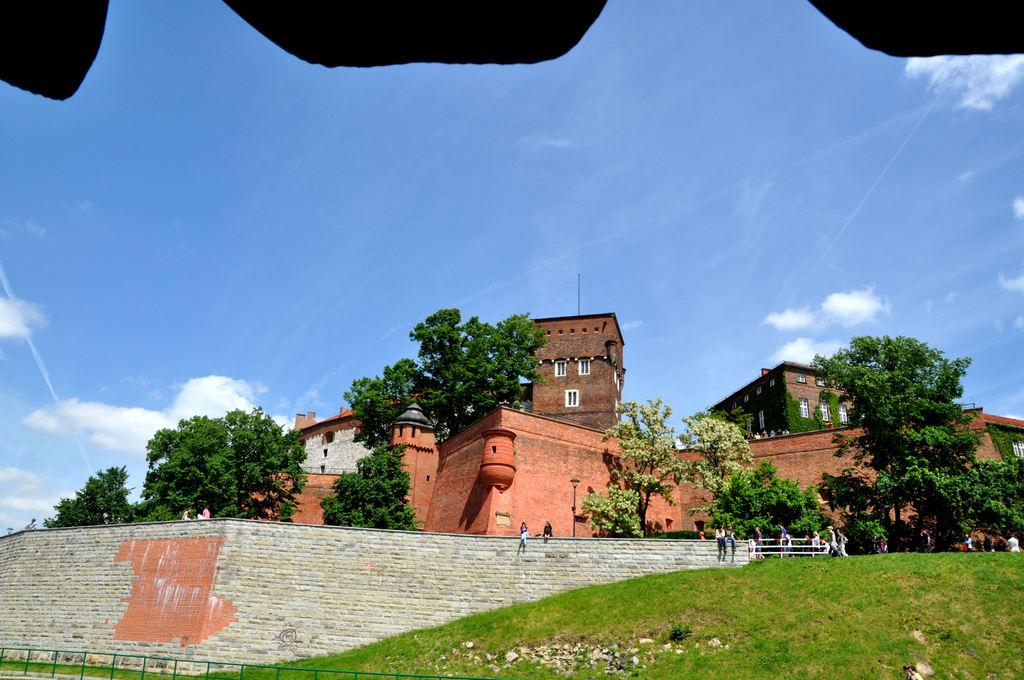What type of vegetation can be seen in the right corner of the image? There are grasses in the right corner of the image. What type of structure is visible in the background of the image? There is a brick wall in the background of the image. What other natural elements can be seen in the background of the image? There are trees in the background of the image. Can you describe the building in the background of the image? There is a building with windows in the background of the image. What is visible in the sky in the background of the image? The sky with clouds is visible in the background of the image. How many people are present in the image? There are many people in the image. What type of juice is being served to the people in the image? There is no juice present in the image; it features grasses, a brick wall, trees, a building with windows, and many people. How many spiders are crawling on the brick wall in the image? There are no spiders visible on the brick wall in the image. 